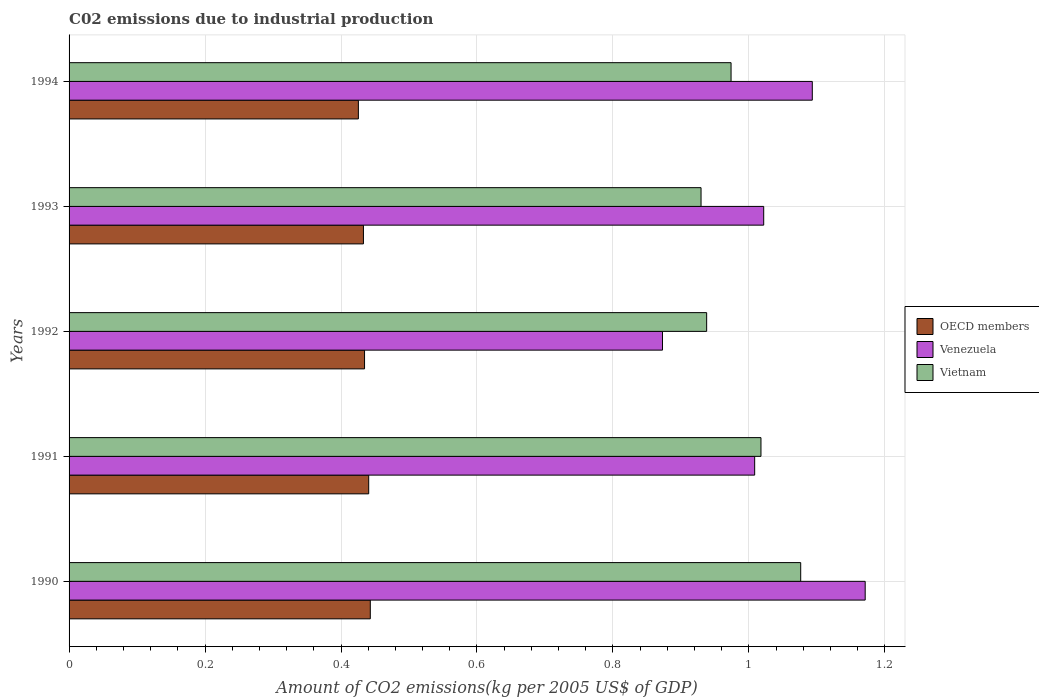How many groups of bars are there?
Provide a short and direct response. 5. Are the number of bars per tick equal to the number of legend labels?
Your answer should be compact. Yes. Are the number of bars on each tick of the Y-axis equal?
Offer a very short reply. Yes. What is the amount of CO2 emitted due to industrial production in Vietnam in 1992?
Provide a succinct answer. 0.94. Across all years, what is the maximum amount of CO2 emitted due to industrial production in OECD members?
Keep it short and to the point. 0.44. Across all years, what is the minimum amount of CO2 emitted due to industrial production in Venezuela?
Provide a succinct answer. 0.87. In which year was the amount of CO2 emitted due to industrial production in Venezuela maximum?
Offer a terse response. 1990. What is the total amount of CO2 emitted due to industrial production in Vietnam in the graph?
Your response must be concise. 4.94. What is the difference between the amount of CO2 emitted due to industrial production in Venezuela in 1992 and that in 1994?
Offer a very short reply. -0.22. What is the difference between the amount of CO2 emitted due to industrial production in Vietnam in 1994 and the amount of CO2 emitted due to industrial production in Venezuela in 1991?
Keep it short and to the point. -0.03. What is the average amount of CO2 emitted due to industrial production in Vietnam per year?
Provide a short and direct response. 0.99. In the year 1993, what is the difference between the amount of CO2 emitted due to industrial production in OECD members and amount of CO2 emitted due to industrial production in Venezuela?
Your response must be concise. -0.59. In how many years, is the amount of CO2 emitted due to industrial production in OECD members greater than 0.7600000000000001 kg?
Make the answer very short. 0. What is the ratio of the amount of CO2 emitted due to industrial production in OECD members in 1990 to that in 1991?
Ensure brevity in your answer.  1.01. Is the difference between the amount of CO2 emitted due to industrial production in OECD members in 1992 and 1994 greater than the difference between the amount of CO2 emitted due to industrial production in Venezuela in 1992 and 1994?
Offer a terse response. Yes. What is the difference between the highest and the second highest amount of CO2 emitted due to industrial production in Venezuela?
Offer a very short reply. 0.08. What is the difference between the highest and the lowest amount of CO2 emitted due to industrial production in Venezuela?
Your response must be concise. 0.3. In how many years, is the amount of CO2 emitted due to industrial production in Vietnam greater than the average amount of CO2 emitted due to industrial production in Vietnam taken over all years?
Offer a terse response. 2. Is the sum of the amount of CO2 emitted due to industrial production in OECD members in 1992 and 1994 greater than the maximum amount of CO2 emitted due to industrial production in Vietnam across all years?
Provide a succinct answer. No. What does the 2nd bar from the bottom in 1991 represents?
Your response must be concise. Venezuela. Is it the case that in every year, the sum of the amount of CO2 emitted due to industrial production in OECD members and amount of CO2 emitted due to industrial production in Venezuela is greater than the amount of CO2 emitted due to industrial production in Vietnam?
Offer a terse response. Yes. How many bars are there?
Give a very brief answer. 15. Are all the bars in the graph horizontal?
Keep it short and to the point. Yes. How many years are there in the graph?
Your answer should be very brief. 5. What is the difference between two consecutive major ticks on the X-axis?
Provide a succinct answer. 0.2. Does the graph contain any zero values?
Your answer should be compact. No. Does the graph contain grids?
Make the answer very short. Yes. What is the title of the graph?
Your response must be concise. C02 emissions due to industrial production. What is the label or title of the X-axis?
Give a very brief answer. Amount of CO2 emissions(kg per 2005 US$ of GDP). What is the label or title of the Y-axis?
Provide a succinct answer. Years. What is the Amount of CO2 emissions(kg per 2005 US$ of GDP) in OECD members in 1990?
Keep it short and to the point. 0.44. What is the Amount of CO2 emissions(kg per 2005 US$ of GDP) of Venezuela in 1990?
Offer a terse response. 1.17. What is the Amount of CO2 emissions(kg per 2005 US$ of GDP) in Vietnam in 1990?
Your response must be concise. 1.08. What is the Amount of CO2 emissions(kg per 2005 US$ of GDP) of OECD members in 1991?
Your answer should be compact. 0.44. What is the Amount of CO2 emissions(kg per 2005 US$ of GDP) of Venezuela in 1991?
Make the answer very short. 1.01. What is the Amount of CO2 emissions(kg per 2005 US$ of GDP) in Vietnam in 1991?
Provide a short and direct response. 1.02. What is the Amount of CO2 emissions(kg per 2005 US$ of GDP) in OECD members in 1992?
Your answer should be compact. 0.43. What is the Amount of CO2 emissions(kg per 2005 US$ of GDP) of Venezuela in 1992?
Your answer should be very brief. 0.87. What is the Amount of CO2 emissions(kg per 2005 US$ of GDP) in Vietnam in 1992?
Your answer should be compact. 0.94. What is the Amount of CO2 emissions(kg per 2005 US$ of GDP) in OECD members in 1993?
Provide a succinct answer. 0.43. What is the Amount of CO2 emissions(kg per 2005 US$ of GDP) in Venezuela in 1993?
Keep it short and to the point. 1.02. What is the Amount of CO2 emissions(kg per 2005 US$ of GDP) in Vietnam in 1993?
Keep it short and to the point. 0.93. What is the Amount of CO2 emissions(kg per 2005 US$ of GDP) in OECD members in 1994?
Make the answer very short. 0.43. What is the Amount of CO2 emissions(kg per 2005 US$ of GDP) of Venezuela in 1994?
Your response must be concise. 1.09. What is the Amount of CO2 emissions(kg per 2005 US$ of GDP) of Vietnam in 1994?
Keep it short and to the point. 0.97. Across all years, what is the maximum Amount of CO2 emissions(kg per 2005 US$ of GDP) of OECD members?
Provide a succinct answer. 0.44. Across all years, what is the maximum Amount of CO2 emissions(kg per 2005 US$ of GDP) in Venezuela?
Make the answer very short. 1.17. Across all years, what is the maximum Amount of CO2 emissions(kg per 2005 US$ of GDP) in Vietnam?
Offer a terse response. 1.08. Across all years, what is the minimum Amount of CO2 emissions(kg per 2005 US$ of GDP) in OECD members?
Give a very brief answer. 0.43. Across all years, what is the minimum Amount of CO2 emissions(kg per 2005 US$ of GDP) of Venezuela?
Your answer should be very brief. 0.87. Across all years, what is the minimum Amount of CO2 emissions(kg per 2005 US$ of GDP) in Vietnam?
Offer a very short reply. 0.93. What is the total Amount of CO2 emissions(kg per 2005 US$ of GDP) in OECD members in the graph?
Offer a very short reply. 2.18. What is the total Amount of CO2 emissions(kg per 2005 US$ of GDP) of Venezuela in the graph?
Make the answer very short. 5.17. What is the total Amount of CO2 emissions(kg per 2005 US$ of GDP) in Vietnam in the graph?
Offer a terse response. 4.94. What is the difference between the Amount of CO2 emissions(kg per 2005 US$ of GDP) in OECD members in 1990 and that in 1991?
Keep it short and to the point. 0. What is the difference between the Amount of CO2 emissions(kg per 2005 US$ of GDP) in Venezuela in 1990 and that in 1991?
Provide a succinct answer. 0.16. What is the difference between the Amount of CO2 emissions(kg per 2005 US$ of GDP) in Vietnam in 1990 and that in 1991?
Make the answer very short. 0.06. What is the difference between the Amount of CO2 emissions(kg per 2005 US$ of GDP) in OECD members in 1990 and that in 1992?
Offer a very short reply. 0.01. What is the difference between the Amount of CO2 emissions(kg per 2005 US$ of GDP) of Venezuela in 1990 and that in 1992?
Provide a short and direct response. 0.3. What is the difference between the Amount of CO2 emissions(kg per 2005 US$ of GDP) in Vietnam in 1990 and that in 1992?
Provide a succinct answer. 0.14. What is the difference between the Amount of CO2 emissions(kg per 2005 US$ of GDP) of OECD members in 1990 and that in 1993?
Make the answer very short. 0.01. What is the difference between the Amount of CO2 emissions(kg per 2005 US$ of GDP) of Venezuela in 1990 and that in 1993?
Provide a succinct answer. 0.15. What is the difference between the Amount of CO2 emissions(kg per 2005 US$ of GDP) in Vietnam in 1990 and that in 1993?
Your answer should be compact. 0.15. What is the difference between the Amount of CO2 emissions(kg per 2005 US$ of GDP) of OECD members in 1990 and that in 1994?
Offer a very short reply. 0.02. What is the difference between the Amount of CO2 emissions(kg per 2005 US$ of GDP) in Venezuela in 1990 and that in 1994?
Give a very brief answer. 0.08. What is the difference between the Amount of CO2 emissions(kg per 2005 US$ of GDP) of Vietnam in 1990 and that in 1994?
Your answer should be compact. 0.1. What is the difference between the Amount of CO2 emissions(kg per 2005 US$ of GDP) of OECD members in 1991 and that in 1992?
Provide a succinct answer. 0.01. What is the difference between the Amount of CO2 emissions(kg per 2005 US$ of GDP) in Venezuela in 1991 and that in 1992?
Offer a very short reply. 0.14. What is the difference between the Amount of CO2 emissions(kg per 2005 US$ of GDP) of Vietnam in 1991 and that in 1992?
Give a very brief answer. 0.08. What is the difference between the Amount of CO2 emissions(kg per 2005 US$ of GDP) of OECD members in 1991 and that in 1993?
Keep it short and to the point. 0.01. What is the difference between the Amount of CO2 emissions(kg per 2005 US$ of GDP) in Venezuela in 1991 and that in 1993?
Offer a very short reply. -0.01. What is the difference between the Amount of CO2 emissions(kg per 2005 US$ of GDP) in Vietnam in 1991 and that in 1993?
Offer a very short reply. 0.09. What is the difference between the Amount of CO2 emissions(kg per 2005 US$ of GDP) in OECD members in 1991 and that in 1994?
Ensure brevity in your answer.  0.02. What is the difference between the Amount of CO2 emissions(kg per 2005 US$ of GDP) of Venezuela in 1991 and that in 1994?
Offer a terse response. -0.08. What is the difference between the Amount of CO2 emissions(kg per 2005 US$ of GDP) in Vietnam in 1991 and that in 1994?
Give a very brief answer. 0.04. What is the difference between the Amount of CO2 emissions(kg per 2005 US$ of GDP) of OECD members in 1992 and that in 1993?
Give a very brief answer. 0. What is the difference between the Amount of CO2 emissions(kg per 2005 US$ of GDP) in Venezuela in 1992 and that in 1993?
Your response must be concise. -0.15. What is the difference between the Amount of CO2 emissions(kg per 2005 US$ of GDP) in Vietnam in 1992 and that in 1993?
Your answer should be compact. 0.01. What is the difference between the Amount of CO2 emissions(kg per 2005 US$ of GDP) in OECD members in 1992 and that in 1994?
Provide a short and direct response. 0.01. What is the difference between the Amount of CO2 emissions(kg per 2005 US$ of GDP) of Venezuela in 1992 and that in 1994?
Your answer should be very brief. -0.22. What is the difference between the Amount of CO2 emissions(kg per 2005 US$ of GDP) in Vietnam in 1992 and that in 1994?
Provide a short and direct response. -0.04. What is the difference between the Amount of CO2 emissions(kg per 2005 US$ of GDP) in OECD members in 1993 and that in 1994?
Make the answer very short. 0.01. What is the difference between the Amount of CO2 emissions(kg per 2005 US$ of GDP) in Venezuela in 1993 and that in 1994?
Offer a terse response. -0.07. What is the difference between the Amount of CO2 emissions(kg per 2005 US$ of GDP) in Vietnam in 1993 and that in 1994?
Your response must be concise. -0.04. What is the difference between the Amount of CO2 emissions(kg per 2005 US$ of GDP) of OECD members in 1990 and the Amount of CO2 emissions(kg per 2005 US$ of GDP) of Venezuela in 1991?
Ensure brevity in your answer.  -0.57. What is the difference between the Amount of CO2 emissions(kg per 2005 US$ of GDP) in OECD members in 1990 and the Amount of CO2 emissions(kg per 2005 US$ of GDP) in Vietnam in 1991?
Your answer should be very brief. -0.57. What is the difference between the Amount of CO2 emissions(kg per 2005 US$ of GDP) of Venezuela in 1990 and the Amount of CO2 emissions(kg per 2005 US$ of GDP) of Vietnam in 1991?
Your response must be concise. 0.15. What is the difference between the Amount of CO2 emissions(kg per 2005 US$ of GDP) in OECD members in 1990 and the Amount of CO2 emissions(kg per 2005 US$ of GDP) in Venezuela in 1992?
Provide a short and direct response. -0.43. What is the difference between the Amount of CO2 emissions(kg per 2005 US$ of GDP) in OECD members in 1990 and the Amount of CO2 emissions(kg per 2005 US$ of GDP) in Vietnam in 1992?
Provide a short and direct response. -0.49. What is the difference between the Amount of CO2 emissions(kg per 2005 US$ of GDP) in Venezuela in 1990 and the Amount of CO2 emissions(kg per 2005 US$ of GDP) in Vietnam in 1992?
Your answer should be compact. 0.23. What is the difference between the Amount of CO2 emissions(kg per 2005 US$ of GDP) of OECD members in 1990 and the Amount of CO2 emissions(kg per 2005 US$ of GDP) of Venezuela in 1993?
Your answer should be compact. -0.58. What is the difference between the Amount of CO2 emissions(kg per 2005 US$ of GDP) of OECD members in 1990 and the Amount of CO2 emissions(kg per 2005 US$ of GDP) of Vietnam in 1993?
Give a very brief answer. -0.49. What is the difference between the Amount of CO2 emissions(kg per 2005 US$ of GDP) in Venezuela in 1990 and the Amount of CO2 emissions(kg per 2005 US$ of GDP) in Vietnam in 1993?
Provide a succinct answer. 0.24. What is the difference between the Amount of CO2 emissions(kg per 2005 US$ of GDP) of OECD members in 1990 and the Amount of CO2 emissions(kg per 2005 US$ of GDP) of Venezuela in 1994?
Your answer should be compact. -0.65. What is the difference between the Amount of CO2 emissions(kg per 2005 US$ of GDP) of OECD members in 1990 and the Amount of CO2 emissions(kg per 2005 US$ of GDP) of Vietnam in 1994?
Provide a short and direct response. -0.53. What is the difference between the Amount of CO2 emissions(kg per 2005 US$ of GDP) in Venezuela in 1990 and the Amount of CO2 emissions(kg per 2005 US$ of GDP) in Vietnam in 1994?
Give a very brief answer. 0.2. What is the difference between the Amount of CO2 emissions(kg per 2005 US$ of GDP) of OECD members in 1991 and the Amount of CO2 emissions(kg per 2005 US$ of GDP) of Venezuela in 1992?
Your response must be concise. -0.43. What is the difference between the Amount of CO2 emissions(kg per 2005 US$ of GDP) of OECD members in 1991 and the Amount of CO2 emissions(kg per 2005 US$ of GDP) of Vietnam in 1992?
Make the answer very short. -0.5. What is the difference between the Amount of CO2 emissions(kg per 2005 US$ of GDP) of Venezuela in 1991 and the Amount of CO2 emissions(kg per 2005 US$ of GDP) of Vietnam in 1992?
Keep it short and to the point. 0.07. What is the difference between the Amount of CO2 emissions(kg per 2005 US$ of GDP) in OECD members in 1991 and the Amount of CO2 emissions(kg per 2005 US$ of GDP) in Venezuela in 1993?
Your answer should be compact. -0.58. What is the difference between the Amount of CO2 emissions(kg per 2005 US$ of GDP) in OECD members in 1991 and the Amount of CO2 emissions(kg per 2005 US$ of GDP) in Vietnam in 1993?
Make the answer very short. -0.49. What is the difference between the Amount of CO2 emissions(kg per 2005 US$ of GDP) in Venezuela in 1991 and the Amount of CO2 emissions(kg per 2005 US$ of GDP) in Vietnam in 1993?
Keep it short and to the point. 0.08. What is the difference between the Amount of CO2 emissions(kg per 2005 US$ of GDP) of OECD members in 1991 and the Amount of CO2 emissions(kg per 2005 US$ of GDP) of Venezuela in 1994?
Your answer should be compact. -0.65. What is the difference between the Amount of CO2 emissions(kg per 2005 US$ of GDP) in OECD members in 1991 and the Amount of CO2 emissions(kg per 2005 US$ of GDP) in Vietnam in 1994?
Ensure brevity in your answer.  -0.53. What is the difference between the Amount of CO2 emissions(kg per 2005 US$ of GDP) in Venezuela in 1991 and the Amount of CO2 emissions(kg per 2005 US$ of GDP) in Vietnam in 1994?
Offer a very short reply. 0.03. What is the difference between the Amount of CO2 emissions(kg per 2005 US$ of GDP) in OECD members in 1992 and the Amount of CO2 emissions(kg per 2005 US$ of GDP) in Venezuela in 1993?
Your response must be concise. -0.59. What is the difference between the Amount of CO2 emissions(kg per 2005 US$ of GDP) in OECD members in 1992 and the Amount of CO2 emissions(kg per 2005 US$ of GDP) in Vietnam in 1993?
Give a very brief answer. -0.49. What is the difference between the Amount of CO2 emissions(kg per 2005 US$ of GDP) in Venezuela in 1992 and the Amount of CO2 emissions(kg per 2005 US$ of GDP) in Vietnam in 1993?
Ensure brevity in your answer.  -0.06. What is the difference between the Amount of CO2 emissions(kg per 2005 US$ of GDP) in OECD members in 1992 and the Amount of CO2 emissions(kg per 2005 US$ of GDP) in Venezuela in 1994?
Offer a very short reply. -0.66. What is the difference between the Amount of CO2 emissions(kg per 2005 US$ of GDP) of OECD members in 1992 and the Amount of CO2 emissions(kg per 2005 US$ of GDP) of Vietnam in 1994?
Offer a terse response. -0.54. What is the difference between the Amount of CO2 emissions(kg per 2005 US$ of GDP) of Venezuela in 1992 and the Amount of CO2 emissions(kg per 2005 US$ of GDP) of Vietnam in 1994?
Provide a short and direct response. -0.1. What is the difference between the Amount of CO2 emissions(kg per 2005 US$ of GDP) in OECD members in 1993 and the Amount of CO2 emissions(kg per 2005 US$ of GDP) in Venezuela in 1994?
Provide a short and direct response. -0.66. What is the difference between the Amount of CO2 emissions(kg per 2005 US$ of GDP) of OECD members in 1993 and the Amount of CO2 emissions(kg per 2005 US$ of GDP) of Vietnam in 1994?
Your answer should be very brief. -0.54. What is the difference between the Amount of CO2 emissions(kg per 2005 US$ of GDP) of Venezuela in 1993 and the Amount of CO2 emissions(kg per 2005 US$ of GDP) of Vietnam in 1994?
Provide a succinct answer. 0.05. What is the average Amount of CO2 emissions(kg per 2005 US$ of GDP) of OECD members per year?
Provide a succinct answer. 0.44. What is the average Amount of CO2 emissions(kg per 2005 US$ of GDP) of Venezuela per year?
Ensure brevity in your answer.  1.03. What is the average Amount of CO2 emissions(kg per 2005 US$ of GDP) of Vietnam per year?
Your answer should be very brief. 0.99. In the year 1990, what is the difference between the Amount of CO2 emissions(kg per 2005 US$ of GDP) of OECD members and Amount of CO2 emissions(kg per 2005 US$ of GDP) of Venezuela?
Keep it short and to the point. -0.73. In the year 1990, what is the difference between the Amount of CO2 emissions(kg per 2005 US$ of GDP) of OECD members and Amount of CO2 emissions(kg per 2005 US$ of GDP) of Vietnam?
Ensure brevity in your answer.  -0.63. In the year 1990, what is the difference between the Amount of CO2 emissions(kg per 2005 US$ of GDP) in Venezuela and Amount of CO2 emissions(kg per 2005 US$ of GDP) in Vietnam?
Ensure brevity in your answer.  0.09. In the year 1991, what is the difference between the Amount of CO2 emissions(kg per 2005 US$ of GDP) of OECD members and Amount of CO2 emissions(kg per 2005 US$ of GDP) of Venezuela?
Ensure brevity in your answer.  -0.57. In the year 1991, what is the difference between the Amount of CO2 emissions(kg per 2005 US$ of GDP) in OECD members and Amount of CO2 emissions(kg per 2005 US$ of GDP) in Vietnam?
Ensure brevity in your answer.  -0.58. In the year 1991, what is the difference between the Amount of CO2 emissions(kg per 2005 US$ of GDP) in Venezuela and Amount of CO2 emissions(kg per 2005 US$ of GDP) in Vietnam?
Your response must be concise. -0.01. In the year 1992, what is the difference between the Amount of CO2 emissions(kg per 2005 US$ of GDP) of OECD members and Amount of CO2 emissions(kg per 2005 US$ of GDP) of Venezuela?
Your answer should be compact. -0.44. In the year 1992, what is the difference between the Amount of CO2 emissions(kg per 2005 US$ of GDP) in OECD members and Amount of CO2 emissions(kg per 2005 US$ of GDP) in Vietnam?
Give a very brief answer. -0.5. In the year 1992, what is the difference between the Amount of CO2 emissions(kg per 2005 US$ of GDP) in Venezuela and Amount of CO2 emissions(kg per 2005 US$ of GDP) in Vietnam?
Provide a succinct answer. -0.07. In the year 1993, what is the difference between the Amount of CO2 emissions(kg per 2005 US$ of GDP) in OECD members and Amount of CO2 emissions(kg per 2005 US$ of GDP) in Venezuela?
Your answer should be compact. -0.59. In the year 1993, what is the difference between the Amount of CO2 emissions(kg per 2005 US$ of GDP) of OECD members and Amount of CO2 emissions(kg per 2005 US$ of GDP) of Vietnam?
Keep it short and to the point. -0.5. In the year 1993, what is the difference between the Amount of CO2 emissions(kg per 2005 US$ of GDP) in Venezuela and Amount of CO2 emissions(kg per 2005 US$ of GDP) in Vietnam?
Offer a very short reply. 0.09. In the year 1994, what is the difference between the Amount of CO2 emissions(kg per 2005 US$ of GDP) in OECD members and Amount of CO2 emissions(kg per 2005 US$ of GDP) in Venezuela?
Give a very brief answer. -0.67. In the year 1994, what is the difference between the Amount of CO2 emissions(kg per 2005 US$ of GDP) of OECD members and Amount of CO2 emissions(kg per 2005 US$ of GDP) of Vietnam?
Ensure brevity in your answer.  -0.55. In the year 1994, what is the difference between the Amount of CO2 emissions(kg per 2005 US$ of GDP) in Venezuela and Amount of CO2 emissions(kg per 2005 US$ of GDP) in Vietnam?
Your response must be concise. 0.12. What is the ratio of the Amount of CO2 emissions(kg per 2005 US$ of GDP) of Venezuela in 1990 to that in 1991?
Ensure brevity in your answer.  1.16. What is the ratio of the Amount of CO2 emissions(kg per 2005 US$ of GDP) of Vietnam in 1990 to that in 1991?
Your answer should be compact. 1.06. What is the ratio of the Amount of CO2 emissions(kg per 2005 US$ of GDP) of OECD members in 1990 to that in 1992?
Provide a short and direct response. 1.02. What is the ratio of the Amount of CO2 emissions(kg per 2005 US$ of GDP) of Venezuela in 1990 to that in 1992?
Offer a very short reply. 1.34. What is the ratio of the Amount of CO2 emissions(kg per 2005 US$ of GDP) in Vietnam in 1990 to that in 1992?
Ensure brevity in your answer.  1.15. What is the ratio of the Amount of CO2 emissions(kg per 2005 US$ of GDP) in OECD members in 1990 to that in 1993?
Make the answer very short. 1.02. What is the ratio of the Amount of CO2 emissions(kg per 2005 US$ of GDP) in Venezuela in 1990 to that in 1993?
Provide a short and direct response. 1.15. What is the ratio of the Amount of CO2 emissions(kg per 2005 US$ of GDP) in Vietnam in 1990 to that in 1993?
Provide a succinct answer. 1.16. What is the ratio of the Amount of CO2 emissions(kg per 2005 US$ of GDP) of OECD members in 1990 to that in 1994?
Offer a terse response. 1.04. What is the ratio of the Amount of CO2 emissions(kg per 2005 US$ of GDP) of Venezuela in 1990 to that in 1994?
Your answer should be compact. 1.07. What is the ratio of the Amount of CO2 emissions(kg per 2005 US$ of GDP) of Vietnam in 1990 to that in 1994?
Ensure brevity in your answer.  1.11. What is the ratio of the Amount of CO2 emissions(kg per 2005 US$ of GDP) in OECD members in 1991 to that in 1992?
Ensure brevity in your answer.  1.01. What is the ratio of the Amount of CO2 emissions(kg per 2005 US$ of GDP) of Venezuela in 1991 to that in 1992?
Offer a terse response. 1.16. What is the ratio of the Amount of CO2 emissions(kg per 2005 US$ of GDP) of Vietnam in 1991 to that in 1992?
Offer a terse response. 1.09. What is the ratio of the Amount of CO2 emissions(kg per 2005 US$ of GDP) in OECD members in 1991 to that in 1993?
Ensure brevity in your answer.  1.02. What is the ratio of the Amount of CO2 emissions(kg per 2005 US$ of GDP) of Vietnam in 1991 to that in 1993?
Ensure brevity in your answer.  1.09. What is the ratio of the Amount of CO2 emissions(kg per 2005 US$ of GDP) of OECD members in 1991 to that in 1994?
Your response must be concise. 1.04. What is the ratio of the Amount of CO2 emissions(kg per 2005 US$ of GDP) in Venezuela in 1991 to that in 1994?
Your answer should be compact. 0.92. What is the ratio of the Amount of CO2 emissions(kg per 2005 US$ of GDP) in Vietnam in 1991 to that in 1994?
Make the answer very short. 1.05. What is the ratio of the Amount of CO2 emissions(kg per 2005 US$ of GDP) of Venezuela in 1992 to that in 1993?
Offer a terse response. 0.85. What is the ratio of the Amount of CO2 emissions(kg per 2005 US$ of GDP) in Vietnam in 1992 to that in 1993?
Make the answer very short. 1.01. What is the ratio of the Amount of CO2 emissions(kg per 2005 US$ of GDP) of OECD members in 1992 to that in 1994?
Offer a very short reply. 1.02. What is the ratio of the Amount of CO2 emissions(kg per 2005 US$ of GDP) of Venezuela in 1992 to that in 1994?
Your response must be concise. 0.8. What is the ratio of the Amount of CO2 emissions(kg per 2005 US$ of GDP) of Vietnam in 1992 to that in 1994?
Keep it short and to the point. 0.96. What is the ratio of the Amount of CO2 emissions(kg per 2005 US$ of GDP) of OECD members in 1993 to that in 1994?
Your response must be concise. 1.02. What is the ratio of the Amount of CO2 emissions(kg per 2005 US$ of GDP) in Venezuela in 1993 to that in 1994?
Keep it short and to the point. 0.93. What is the ratio of the Amount of CO2 emissions(kg per 2005 US$ of GDP) in Vietnam in 1993 to that in 1994?
Ensure brevity in your answer.  0.95. What is the difference between the highest and the second highest Amount of CO2 emissions(kg per 2005 US$ of GDP) in OECD members?
Make the answer very short. 0. What is the difference between the highest and the second highest Amount of CO2 emissions(kg per 2005 US$ of GDP) in Venezuela?
Keep it short and to the point. 0.08. What is the difference between the highest and the second highest Amount of CO2 emissions(kg per 2005 US$ of GDP) of Vietnam?
Your response must be concise. 0.06. What is the difference between the highest and the lowest Amount of CO2 emissions(kg per 2005 US$ of GDP) of OECD members?
Keep it short and to the point. 0.02. What is the difference between the highest and the lowest Amount of CO2 emissions(kg per 2005 US$ of GDP) in Venezuela?
Your answer should be compact. 0.3. What is the difference between the highest and the lowest Amount of CO2 emissions(kg per 2005 US$ of GDP) in Vietnam?
Provide a short and direct response. 0.15. 